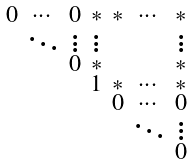<formula> <loc_0><loc_0><loc_500><loc_500>\begin{smallmatrix} 0 & \cdots & 0 & * & * & \cdots & * \\ & \ddots & \vdots & \vdots & & & \vdots \\ & & 0 & * & & & * \\ & & & 1 & * & \cdots & * \\ & & & & 0 & \cdots & 0 \\ & & & & & \ddots & \vdots \\ & & & & & & 0 \end{smallmatrix}</formula> 